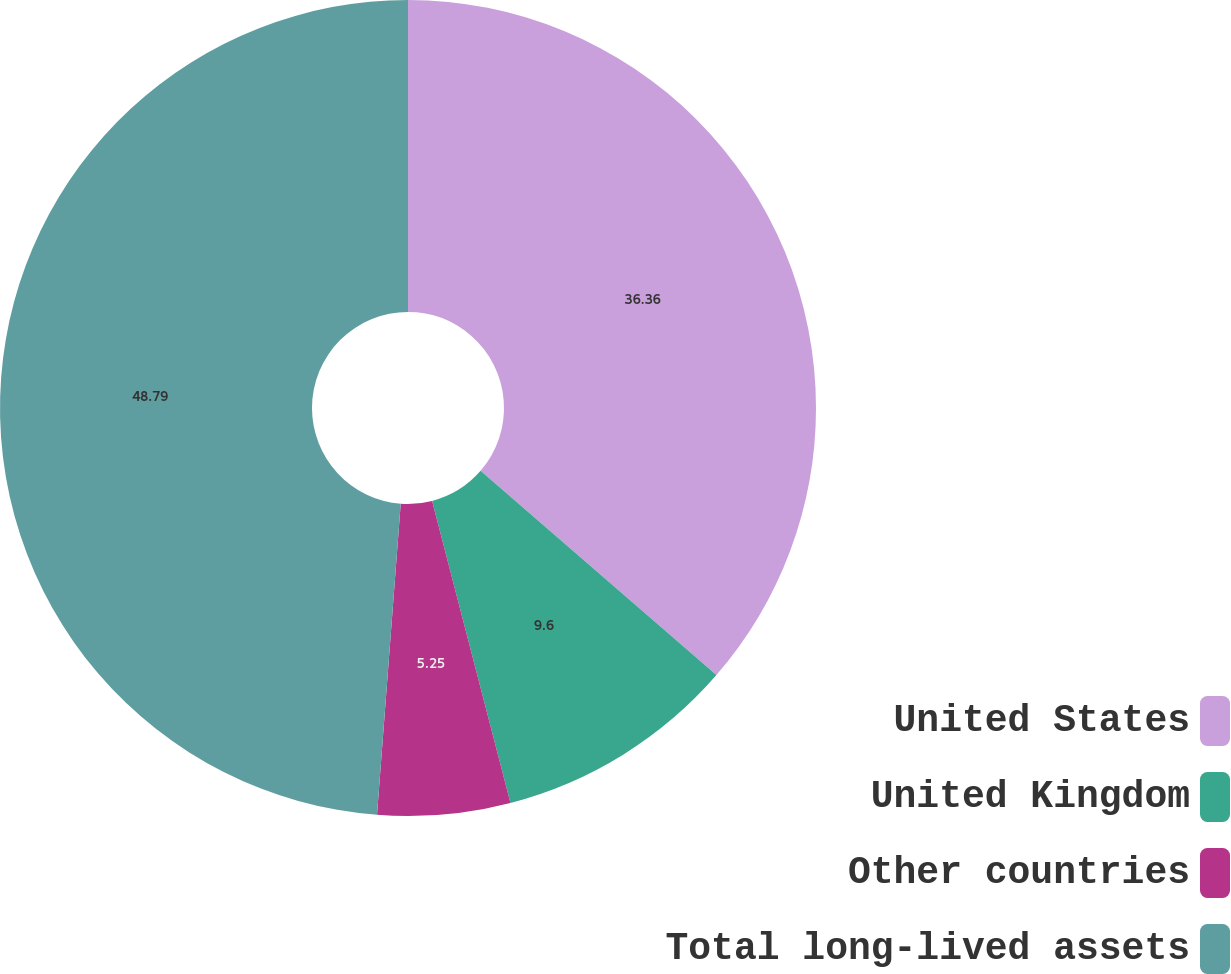Convert chart to OTSL. <chart><loc_0><loc_0><loc_500><loc_500><pie_chart><fcel>United States<fcel>United Kingdom<fcel>Other countries<fcel>Total long-lived assets<nl><fcel>36.36%<fcel>9.6%<fcel>5.25%<fcel>48.79%<nl></chart> 